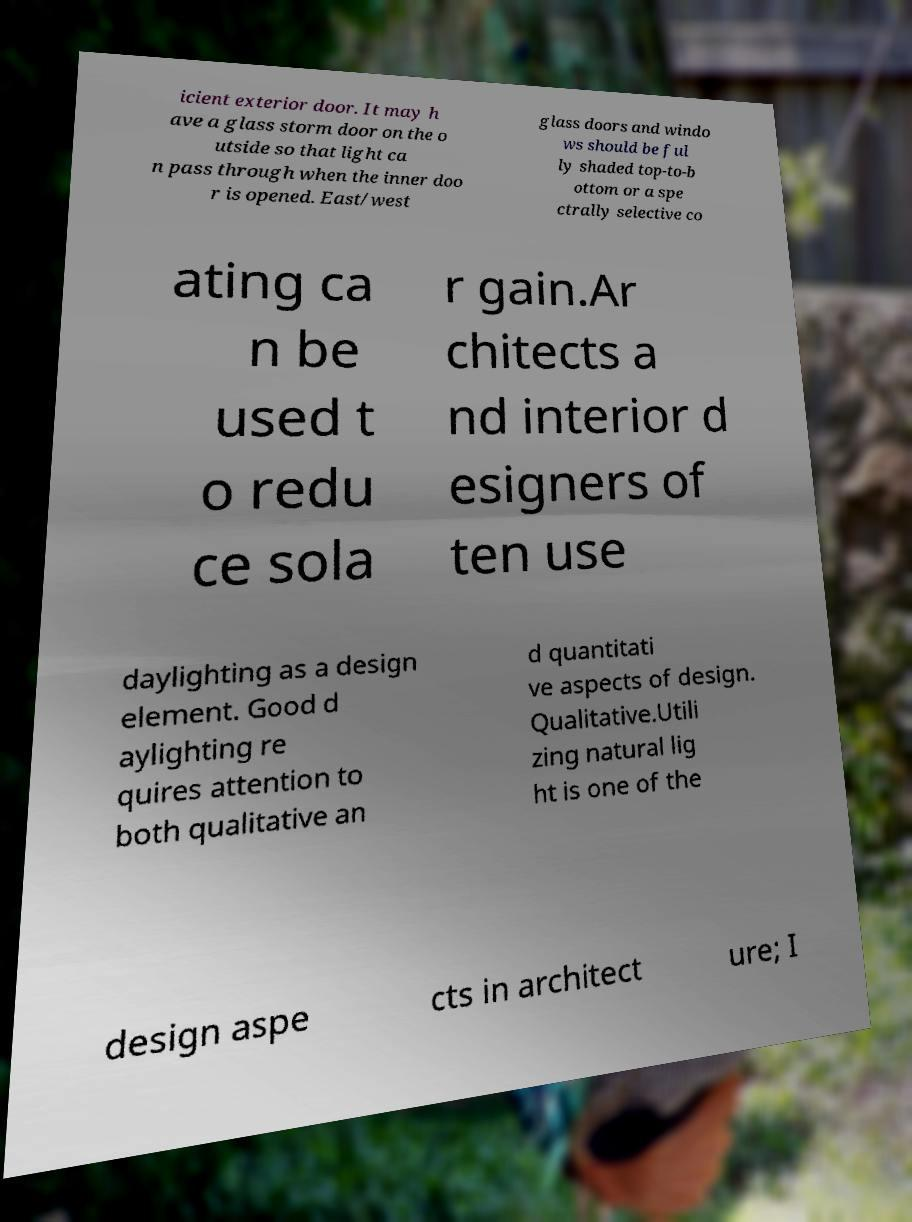Please identify and transcribe the text found in this image. icient exterior door. It may h ave a glass storm door on the o utside so that light ca n pass through when the inner doo r is opened. East/west glass doors and windo ws should be ful ly shaded top-to-b ottom or a spe ctrally selective co ating ca n be used t o redu ce sola r gain.Ar chitects a nd interior d esigners of ten use daylighting as a design element. Good d aylighting re quires attention to both qualitative an d quantitati ve aspects of design. Qualitative.Utili zing natural lig ht is one of the design aspe cts in architect ure; I 